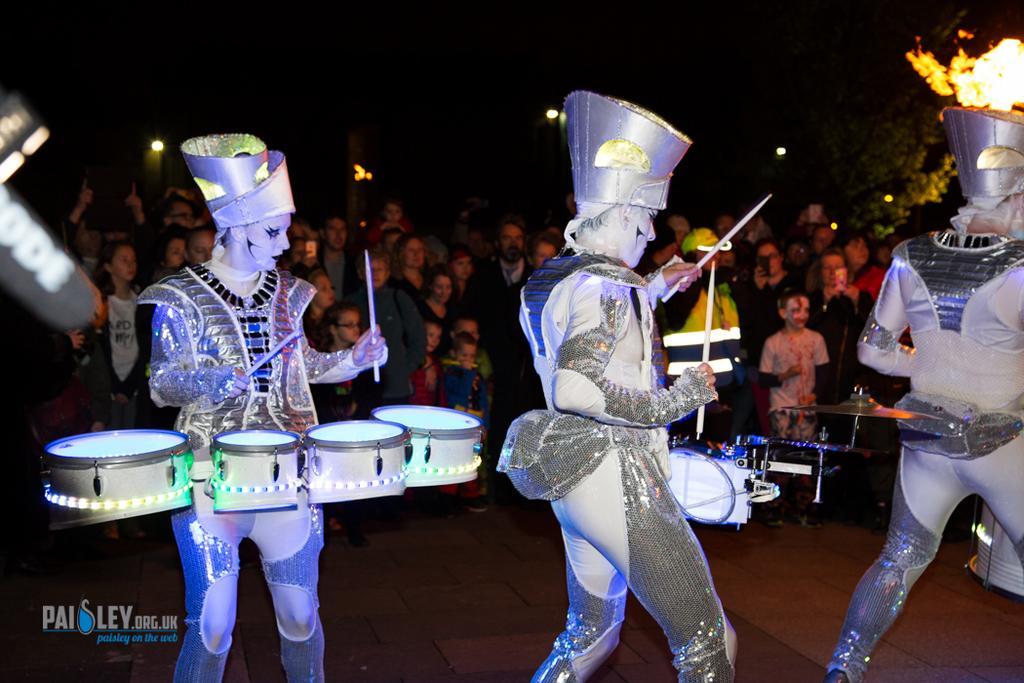Could you give a brief overview of what you see in this image? The picture shows some dancers performing an activity with drums with the different costumes. In the background there are some people watching their performances on the stage. 